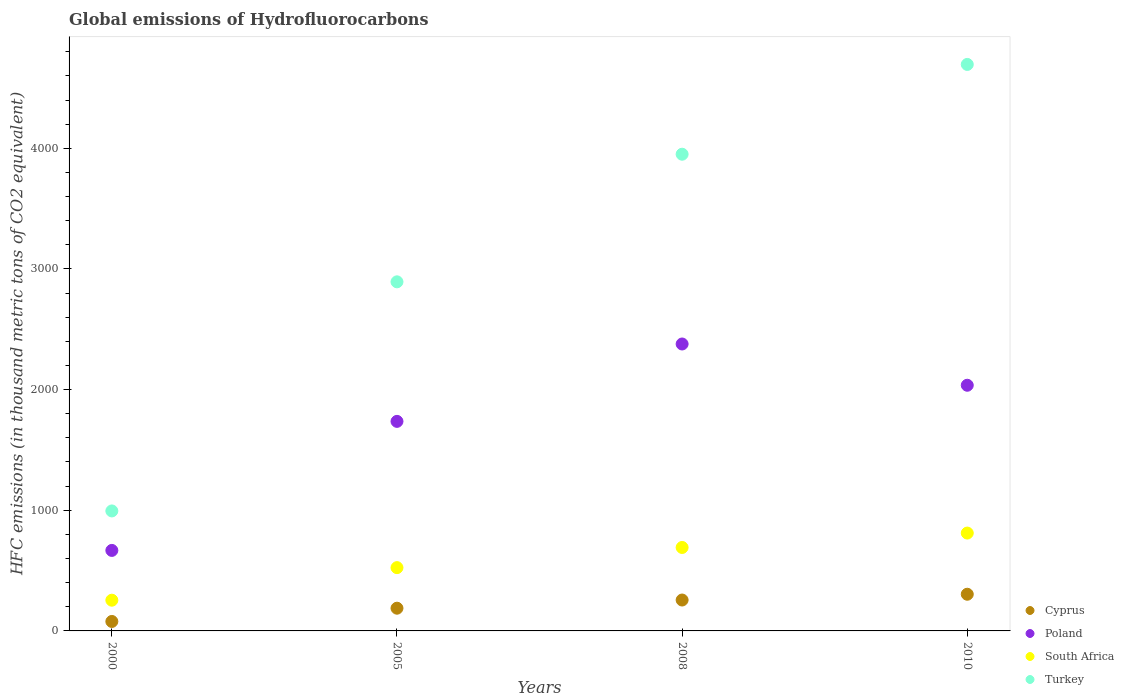How many different coloured dotlines are there?
Keep it short and to the point. 4. Is the number of dotlines equal to the number of legend labels?
Keep it short and to the point. Yes. What is the global emissions of Hydrofluorocarbons in Poland in 2010?
Offer a terse response. 2036. Across all years, what is the maximum global emissions of Hydrofluorocarbons in Poland?
Make the answer very short. 2378. Across all years, what is the minimum global emissions of Hydrofluorocarbons in Turkey?
Your response must be concise. 994.4. What is the total global emissions of Hydrofluorocarbons in Turkey in the graph?
Provide a short and direct response. 1.25e+04. What is the difference between the global emissions of Hydrofluorocarbons in Turkey in 2005 and that in 2008?
Provide a succinct answer. -1057.6. What is the difference between the global emissions of Hydrofluorocarbons in South Africa in 2000 and the global emissions of Hydrofluorocarbons in Turkey in 2010?
Your answer should be very brief. -4440.4. What is the average global emissions of Hydrofluorocarbons in Cyprus per year?
Give a very brief answer. 206.7. In the year 2005, what is the difference between the global emissions of Hydrofluorocarbons in Cyprus and global emissions of Hydrofluorocarbons in South Africa?
Offer a very short reply. -336.2. In how many years, is the global emissions of Hydrofluorocarbons in Cyprus greater than 3000 thousand metric tons?
Give a very brief answer. 0. What is the ratio of the global emissions of Hydrofluorocarbons in Cyprus in 2000 to that in 2010?
Your answer should be compact. 0.26. Is the difference between the global emissions of Hydrofluorocarbons in Cyprus in 2005 and 2010 greater than the difference between the global emissions of Hydrofluorocarbons in South Africa in 2005 and 2010?
Offer a very short reply. Yes. What is the difference between the highest and the second highest global emissions of Hydrofluorocarbons in Turkey?
Offer a very short reply. 744.2. What is the difference between the highest and the lowest global emissions of Hydrofluorocarbons in South Africa?
Keep it short and to the point. 556.4. Is it the case that in every year, the sum of the global emissions of Hydrofluorocarbons in Poland and global emissions of Hydrofluorocarbons in South Africa  is greater than the global emissions of Hydrofluorocarbons in Turkey?
Your response must be concise. No. Does the global emissions of Hydrofluorocarbons in South Africa monotonically increase over the years?
Ensure brevity in your answer.  Yes. Is the global emissions of Hydrofluorocarbons in Poland strictly less than the global emissions of Hydrofluorocarbons in Turkey over the years?
Offer a very short reply. Yes. How many dotlines are there?
Your answer should be very brief. 4. How many years are there in the graph?
Ensure brevity in your answer.  4. Does the graph contain any zero values?
Provide a succinct answer. No. Does the graph contain grids?
Offer a very short reply. No. What is the title of the graph?
Offer a very short reply. Global emissions of Hydrofluorocarbons. What is the label or title of the X-axis?
Keep it short and to the point. Years. What is the label or title of the Y-axis?
Provide a short and direct response. HFC emissions (in thousand metric tons of CO2 equivalent). What is the HFC emissions (in thousand metric tons of CO2 equivalent) of Cyprus in 2000?
Keep it short and to the point. 78.4. What is the HFC emissions (in thousand metric tons of CO2 equivalent) of Poland in 2000?
Provide a succinct answer. 667.2. What is the HFC emissions (in thousand metric tons of CO2 equivalent) of South Africa in 2000?
Your answer should be compact. 254.6. What is the HFC emissions (in thousand metric tons of CO2 equivalent) of Turkey in 2000?
Your answer should be compact. 994.4. What is the HFC emissions (in thousand metric tons of CO2 equivalent) in Cyprus in 2005?
Your answer should be compact. 188.3. What is the HFC emissions (in thousand metric tons of CO2 equivalent) of Poland in 2005?
Give a very brief answer. 1736.7. What is the HFC emissions (in thousand metric tons of CO2 equivalent) of South Africa in 2005?
Your answer should be very brief. 524.5. What is the HFC emissions (in thousand metric tons of CO2 equivalent) of Turkey in 2005?
Your response must be concise. 2893.2. What is the HFC emissions (in thousand metric tons of CO2 equivalent) in Cyprus in 2008?
Provide a succinct answer. 256.1. What is the HFC emissions (in thousand metric tons of CO2 equivalent) in Poland in 2008?
Your answer should be very brief. 2378. What is the HFC emissions (in thousand metric tons of CO2 equivalent) of South Africa in 2008?
Offer a very short reply. 691.6. What is the HFC emissions (in thousand metric tons of CO2 equivalent) of Turkey in 2008?
Provide a short and direct response. 3950.8. What is the HFC emissions (in thousand metric tons of CO2 equivalent) of Cyprus in 2010?
Give a very brief answer. 304. What is the HFC emissions (in thousand metric tons of CO2 equivalent) in Poland in 2010?
Provide a succinct answer. 2036. What is the HFC emissions (in thousand metric tons of CO2 equivalent) of South Africa in 2010?
Give a very brief answer. 811. What is the HFC emissions (in thousand metric tons of CO2 equivalent) in Turkey in 2010?
Ensure brevity in your answer.  4695. Across all years, what is the maximum HFC emissions (in thousand metric tons of CO2 equivalent) in Cyprus?
Make the answer very short. 304. Across all years, what is the maximum HFC emissions (in thousand metric tons of CO2 equivalent) in Poland?
Make the answer very short. 2378. Across all years, what is the maximum HFC emissions (in thousand metric tons of CO2 equivalent) of South Africa?
Your answer should be compact. 811. Across all years, what is the maximum HFC emissions (in thousand metric tons of CO2 equivalent) of Turkey?
Make the answer very short. 4695. Across all years, what is the minimum HFC emissions (in thousand metric tons of CO2 equivalent) in Cyprus?
Keep it short and to the point. 78.4. Across all years, what is the minimum HFC emissions (in thousand metric tons of CO2 equivalent) of Poland?
Provide a succinct answer. 667.2. Across all years, what is the minimum HFC emissions (in thousand metric tons of CO2 equivalent) of South Africa?
Ensure brevity in your answer.  254.6. Across all years, what is the minimum HFC emissions (in thousand metric tons of CO2 equivalent) of Turkey?
Provide a succinct answer. 994.4. What is the total HFC emissions (in thousand metric tons of CO2 equivalent) of Cyprus in the graph?
Provide a succinct answer. 826.8. What is the total HFC emissions (in thousand metric tons of CO2 equivalent) of Poland in the graph?
Offer a very short reply. 6817.9. What is the total HFC emissions (in thousand metric tons of CO2 equivalent) in South Africa in the graph?
Your answer should be compact. 2281.7. What is the total HFC emissions (in thousand metric tons of CO2 equivalent) of Turkey in the graph?
Provide a short and direct response. 1.25e+04. What is the difference between the HFC emissions (in thousand metric tons of CO2 equivalent) in Cyprus in 2000 and that in 2005?
Keep it short and to the point. -109.9. What is the difference between the HFC emissions (in thousand metric tons of CO2 equivalent) in Poland in 2000 and that in 2005?
Provide a short and direct response. -1069.5. What is the difference between the HFC emissions (in thousand metric tons of CO2 equivalent) of South Africa in 2000 and that in 2005?
Make the answer very short. -269.9. What is the difference between the HFC emissions (in thousand metric tons of CO2 equivalent) of Turkey in 2000 and that in 2005?
Offer a very short reply. -1898.8. What is the difference between the HFC emissions (in thousand metric tons of CO2 equivalent) in Cyprus in 2000 and that in 2008?
Your answer should be compact. -177.7. What is the difference between the HFC emissions (in thousand metric tons of CO2 equivalent) of Poland in 2000 and that in 2008?
Provide a succinct answer. -1710.8. What is the difference between the HFC emissions (in thousand metric tons of CO2 equivalent) in South Africa in 2000 and that in 2008?
Offer a very short reply. -437. What is the difference between the HFC emissions (in thousand metric tons of CO2 equivalent) in Turkey in 2000 and that in 2008?
Provide a succinct answer. -2956.4. What is the difference between the HFC emissions (in thousand metric tons of CO2 equivalent) in Cyprus in 2000 and that in 2010?
Provide a succinct answer. -225.6. What is the difference between the HFC emissions (in thousand metric tons of CO2 equivalent) in Poland in 2000 and that in 2010?
Your response must be concise. -1368.8. What is the difference between the HFC emissions (in thousand metric tons of CO2 equivalent) of South Africa in 2000 and that in 2010?
Your answer should be very brief. -556.4. What is the difference between the HFC emissions (in thousand metric tons of CO2 equivalent) of Turkey in 2000 and that in 2010?
Keep it short and to the point. -3700.6. What is the difference between the HFC emissions (in thousand metric tons of CO2 equivalent) of Cyprus in 2005 and that in 2008?
Offer a very short reply. -67.8. What is the difference between the HFC emissions (in thousand metric tons of CO2 equivalent) in Poland in 2005 and that in 2008?
Provide a short and direct response. -641.3. What is the difference between the HFC emissions (in thousand metric tons of CO2 equivalent) in South Africa in 2005 and that in 2008?
Keep it short and to the point. -167.1. What is the difference between the HFC emissions (in thousand metric tons of CO2 equivalent) in Turkey in 2005 and that in 2008?
Provide a short and direct response. -1057.6. What is the difference between the HFC emissions (in thousand metric tons of CO2 equivalent) of Cyprus in 2005 and that in 2010?
Provide a succinct answer. -115.7. What is the difference between the HFC emissions (in thousand metric tons of CO2 equivalent) of Poland in 2005 and that in 2010?
Make the answer very short. -299.3. What is the difference between the HFC emissions (in thousand metric tons of CO2 equivalent) of South Africa in 2005 and that in 2010?
Offer a very short reply. -286.5. What is the difference between the HFC emissions (in thousand metric tons of CO2 equivalent) in Turkey in 2005 and that in 2010?
Provide a succinct answer. -1801.8. What is the difference between the HFC emissions (in thousand metric tons of CO2 equivalent) of Cyprus in 2008 and that in 2010?
Provide a short and direct response. -47.9. What is the difference between the HFC emissions (in thousand metric tons of CO2 equivalent) of Poland in 2008 and that in 2010?
Your answer should be compact. 342. What is the difference between the HFC emissions (in thousand metric tons of CO2 equivalent) of South Africa in 2008 and that in 2010?
Give a very brief answer. -119.4. What is the difference between the HFC emissions (in thousand metric tons of CO2 equivalent) in Turkey in 2008 and that in 2010?
Your answer should be very brief. -744.2. What is the difference between the HFC emissions (in thousand metric tons of CO2 equivalent) in Cyprus in 2000 and the HFC emissions (in thousand metric tons of CO2 equivalent) in Poland in 2005?
Offer a very short reply. -1658.3. What is the difference between the HFC emissions (in thousand metric tons of CO2 equivalent) in Cyprus in 2000 and the HFC emissions (in thousand metric tons of CO2 equivalent) in South Africa in 2005?
Your answer should be compact. -446.1. What is the difference between the HFC emissions (in thousand metric tons of CO2 equivalent) of Cyprus in 2000 and the HFC emissions (in thousand metric tons of CO2 equivalent) of Turkey in 2005?
Keep it short and to the point. -2814.8. What is the difference between the HFC emissions (in thousand metric tons of CO2 equivalent) in Poland in 2000 and the HFC emissions (in thousand metric tons of CO2 equivalent) in South Africa in 2005?
Ensure brevity in your answer.  142.7. What is the difference between the HFC emissions (in thousand metric tons of CO2 equivalent) in Poland in 2000 and the HFC emissions (in thousand metric tons of CO2 equivalent) in Turkey in 2005?
Keep it short and to the point. -2226. What is the difference between the HFC emissions (in thousand metric tons of CO2 equivalent) of South Africa in 2000 and the HFC emissions (in thousand metric tons of CO2 equivalent) of Turkey in 2005?
Provide a succinct answer. -2638.6. What is the difference between the HFC emissions (in thousand metric tons of CO2 equivalent) of Cyprus in 2000 and the HFC emissions (in thousand metric tons of CO2 equivalent) of Poland in 2008?
Keep it short and to the point. -2299.6. What is the difference between the HFC emissions (in thousand metric tons of CO2 equivalent) of Cyprus in 2000 and the HFC emissions (in thousand metric tons of CO2 equivalent) of South Africa in 2008?
Your answer should be compact. -613.2. What is the difference between the HFC emissions (in thousand metric tons of CO2 equivalent) in Cyprus in 2000 and the HFC emissions (in thousand metric tons of CO2 equivalent) in Turkey in 2008?
Give a very brief answer. -3872.4. What is the difference between the HFC emissions (in thousand metric tons of CO2 equivalent) of Poland in 2000 and the HFC emissions (in thousand metric tons of CO2 equivalent) of South Africa in 2008?
Provide a short and direct response. -24.4. What is the difference between the HFC emissions (in thousand metric tons of CO2 equivalent) of Poland in 2000 and the HFC emissions (in thousand metric tons of CO2 equivalent) of Turkey in 2008?
Provide a succinct answer. -3283.6. What is the difference between the HFC emissions (in thousand metric tons of CO2 equivalent) in South Africa in 2000 and the HFC emissions (in thousand metric tons of CO2 equivalent) in Turkey in 2008?
Keep it short and to the point. -3696.2. What is the difference between the HFC emissions (in thousand metric tons of CO2 equivalent) in Cyprus in 2000 and the HFC emissions (in thousand metric tons of CO2 equivalent) in Poland in 2010?
Ensure brevity in your answer.  -1957.6. What is the difference between the HFC emissions (in thousand metric tons of CO2 equivalent) of Cyprus in 2000 and the HFC emissions (in thousand metric tons of CO2 equivalent) of South Africa in 2010?
Provide a short and direct response. -732.6. What is the difference between the HFC emissions (in thousand metric tons of CO2 equivalent) in Cyprus in 2000 and the HFC emissions (in thousand metric tons of CO2 equivalent) in Turkey in 2010?
Offer a very short reply. -4616.6. What is the difference between the HFC emissions (in thousand metric tons of CO2 equivalent) in Poland in 2000 and the HFC emissions (in thousand metric tons of CO2 equivalent) in South Africa in 2010?
Your answer should be very brief. -143.8. What is the difference between the HFC emissions (in thousand metric tons of CO2 equivalent) of Poland in 2000 and the HFC emissions (in thousand metric tons of CO2 equivalent) of Turkey in 2010?
Provide a short and direct response. -4027.8. What is the difference between the HFC emissions (in thousand metric tons of CO2 equivalent) of South Africa in 2000 and the HFC emissions (in thousand metric tons of CO2 equivalent) of Turkey in 2010?
Your answer should be very brief. -4440.4. What is the difference between the HFC emissions (in thousand metric tons of CO2 equivalent) in Cyprus in 2005 and the HFC emissions (in thousand metric tons of CO2 equivalent) in Poland in 2008?
Offer a terse response. -2189.7. What is the difference between the HFC emissions (in thousand metric tons of CO2 equivalent) of Cyprus in 2005 and the HFC emissions (in thousand metric tons of CO2 equivalent) of South Africa in 2008?
Give a very brief answer. -503.3. What is the difference between the HFC emissions (in thousand metric tons of CO2 equivalent) of Cyprus in 2005 and the HFC emissions (in thousand metric tons of CO2 equivalent) of Turkey in 2008?
Provide a succinct answer. -3762.5. What is the difference between the HFC emissions (in thousand metric tons of CO2 equivalent) in Poland in 2005 and the HFC emissions (in thousand metric tons of CO2 equivalent) in South Africa in 2008?
Offer a terse response. 1045.1. What is the difference between the HFC emissions (in thousand metric tons of CO2 equivalent) in Poland in 2005 and the HFC emissions (in thousand metric tons of CO2 equivalent) in Turkey in 2008?
Offer a very short reply. -2214.1. What is the difference between the HFC emissions (in thousand metric tons of CO2 equivalent) of South Africa in 2005 and the HFC emissions (in thousand metric tons of CO2 equivalent) of Turkey in 2008?
Offer a very short reply. -3426.3. What is the difference between the HFC emissions (in thousand metric tons of CO2 equivalent) in Cyprus in 2005 and the HFC emissions (in thousand metric tons of CO2 equivalent) in Poland in 2010?
Give a very brief answer. -1847.7. What is the difference between the HFC emissions (in thousand metric tons of CO2 equivalent) in Cyprus in 2005 and the HFC emissions (in thousand metric tons of CO2 equivalent) in South Africa in 2010?
Ensure brevity in your answer.  -622.7. What is the difference between the HFC emissions (in thousand metric tons of CO2 equivalent) in Cyprus in 2005 and the HFC emissions (in thousand metric tons of CO2 equivalent) in Turkey in 2010?
Give a very brief answer. -4506.7. What is the difference between the HFC emissions (in thousand metric tons of CO2 equivalent) in Poland in 2005 and the HFC emissions (in thousand metric tons of CO2 equivalent) in South Africa in 2010?
Give a very brief answer. 925.7. What is the difference between the HFC emissions (in thousand metric tons of CO2 equivalent) in Poland in 2005 and the HFC emissions (in thousand metric tons of CO2 equivalent) in Turkey in 2010?
Keep it short and to the point. -2958.3. What is the difference between the HFC emissions (in thousand metric tons of CO2 equivalent) in South Africa in 2005 and the HFC emissions (in thousand metric tons of CO2 equivalent) in Turkey in 2010?
Keep it short and to the point. -4170.5. What is the difference between the HFC emissions (in thousand metric tons of CO2 equivalent) in Cyprus in 2008 and the HFC emissions (in thousand metric tons of CO2 equivalent) in Poland in 2010?
Offer a terse response. -1779.9. What is the difference between the HFC emissions (in thousand metric tons of CO2 equivalent) in Cyprus in 2008 and the HFC emissions (in thousand metric tons of CO2 equivalent) in South Africa in 2010?
Keep it short and to the point. -554.9. What is the difference between the HFC emissions (in thousand metric tons of CO2 equivalent) in Cyprus in 2008 and the HFC emissions (in thousand metric tons of CO2 equivalent) in Turkey in 2010?
Your answer should be compact. -4438.9. What is the difference between the HFC emissions (in thousand metric tons of CO2 equivalent) in Poland in 2008 and the HFC emissions (in thousand metric tons of CO2 equivalent) in South Africa in 2010?
Make the answer very short. 1567. What is the difference between the HFC emissions (in thousand metric tons of CO2 equivalent) of Poland in 2008 and the HFC emissions (in thousand metric tons of CO2 equivalent) of Turkey in 2010?
Offer a terse response. -2317. What is the difference between the HFC emissions (in thousand metric tons of CO2 equivalent) in South Africa in 2008 and the HFC emissions (in thousand metric tons of CO2 equivalent) in Turkey in 2010?
Make the answer very short. -4003.4. What is the average HFC emissions (in thousand metric tons of CO2 equivalent) of Cyprus per year?
Keep it short and to the point. 206.7. What is the average HFC emissions (in thousand metric tons of CO2 equivalent) of Poland per year?
Provide a succinct answer. 1704.47. What is the average HFC emissions (in thousand metric tons of CO2 equivalent) in South Africa per year?
Provide a short and direct response. 570.42. What is the average HFC emissions (in thousand metric tons of CO2 equivalent) in Turkey per year?
Offer a very short reply. 3133.35. In the year 2000, what is the difference between the HFC emissions (in thousand metric tons of CO2 equivalent) in Cyprus and HFC emissions (in thousand metric tons of CO2 equivalent) in Poland?
Provide a short and direct response. -588.8. In the year 2000, what is the difference between the HFC emissions (in thousand metric tons of CO2 equivalent) in Cyprus and HFC emissions (in thousand metric tons of CO2 equivalent) in South Africa?
Give a very brief answer. -176.2. In the year 2000, what is the difference between the HFC emissions (in thousand metric tons of CO2 equivalent) in Cyprus and HFC emissions (in thousand metric tons of CO2 equivalent) in Turkey?
Offer a terse response. -916. In the year 2000, what is the difference between the HFC emissions (in thousand metric tons of CO2 equivalent) of Poland and HFC emissions (in thousand metric tons of CO2 equivalent) of South Africa?
Your answer should be compact. 412.6. In the year 2000, what is the difference between the HFC emissions (in thousand metric tons of CO2 equivalent) in Poland and HFC emissions (in thousand metric tons of CO2 equivalent) in Turkey?
Your response must be concise. -327.2. In the year 2000, what is the difference between the HFC emissions (in thousand metric tons of CO2 equivalent) of South Africa and HFC emissions (in thousand metric tons of CO2 equivalent) of Turkey?
Your response must be concise. -739.8. In the year 2005, what is the difference between the HFC emissions (in thousand metric tons of CO2 equivalent) in Cyprus and HFC emissions (in thousand metric tons of CO2 equivalent) in Poland?
Your answer should be very brief. -1548.4. In the year 2005, what is the difference between the HFC emissions (in thousand metric tons of CO2 equivalent) in Cyprus and HFC emissions (in thousand metric tons of CO2 equivalent) in South Africa?
Your answer should be compact. -336.2. In the year 2005, what is the difference between the HFC emissions (in thousand metric tons of CO2 equivalent) in Cyprus and HFC emissions (in thousand metric tons of CO2 equivalent) in Turkey?
Make the answer very short. -2704.9. In the year 2005, what is the difference between the HFC emissions (in thousand metric tons of CO2 equivalent) in Poland and HFC emissions (in thousand metric tons of CO2 equivalent) in South Africa?
Keep it short and to the point. 1212.2. In the year 2005, what is the difference between the HFC emissions (in thousand metric tons of CO2 equivalent) in Poland and HFC emissions (in thousand metric tons of CO2 equivalent) in Turkey?
Offer a terse response. -1156.5. In the year 2005, what is the difference between the HFC emissions (in thousand metric tons of CO2 equivalent) of South Africa and HFC emissions (in thousand metric tons of CO2 equivalent) of Turkey?
Provide a short and direct response. -2368.7. In the year 2008, what is the difference between the HFC emissions (in thousand metric tons of CO2 equivalent) in Cyprus and HFC emissions (in thousand metric tons of CO2 equivalent) in Poland?
Keep it short and to the point. -2121.9. In the year 2008, what is the difference between the HFC emissions (in thousand metric tons of CO2 equivalent) of Cyprus and HFC emissions (in thousand metric tons of CO2 equivalent) of South Africa?
Your answer should be very brief. -435.5. In the year 2008, what is the difference between the HFC emissions (in thousand metric tons of CO2 equivalent) in Cyprus and HFC emissions (in thousand metric tons of CO2 equivalent) in Turkey?
Provide a short and direct response. -3694.7. In the year 2008, what is the difference between the HFC emissions (in thousand metric tons of CO2 equivalent) in Poland and HFC emissions (in thousand metric tons of CO2 equivalent) in South Africa?
Offer a terse response. 1686.4. In the year 2008, what is the difference between the HFC emissions (in thousand metric tons of CO2 equivalent) in Poland and HFC emissions (in thousand metric tons of CO2 equivalent) in Turkey?
Your answer should be compact. -1572.8. In the year 2008, what is the difference between the HFC emissions (in thousand metric tons of CO2 equivalent) in South Africa and HFC emissions (in thousand metric tons of CO2 equivalent) in Turkey?
Keep it short and to the point. -3259.2. In the year 2010, what is the difference between the HFC emissions (in thousand metric tons of CO2 equivalent) in Cyprus and HFC emissions (in thousand metric tons of CO2 equivalent) in Poland?
Give a very brief answer. -1732. In the year 2010, what is the difference between the HFC emissions (in thousand metric tons of CO2 equivalent) in Cyprus and HFC emissions (in thousand metric tons of CO2 equivalent) in South Africa?
Offer a very short reply. -507. In the year 2010, what is the difference between the HFC emissions (in thousand metric tons of CO2 equivalent) of Cyprus and HFC emissions (in thousand metric tons of CO2 equivalent) of Turkey?
Ensure brevity in your answer.  -4391. In the year 2010, what is the difference between the HFC emissions (in thousand metric tons of CO2 equivalent) in Poland and HFC emissions (in thousand metric tons of CO2 equivalent) in South Africa?
Offer a very short reply. 1225. In the year 2010, what is the difference between the HFC emissions (in thousand metric tons of CO2 equivalent) of Poland and HFC emissions (in thousand metric tons of CO2 equivalent) of Turkey?
Provide a succinct answer. -2659. In the year 2010, what is the difference between the HFC emissions (in thousand metric tons of CO2 equivalent) in South Africa and HFC emissions (in thousand metric tons of CO2 equivalent) in Turkey?
Keep it short and to the point. -3884. What is the ratio of the HFC emissions (in thousand metric tons of CO2 equivalent) of Cyprus in 2000 to that in 2005?
Ensure brevity in your answer.  0.42. What is the ratio of the HFC emissions (in thousand metric tons of CO2 equivalent) in Poland in 2000 to that in 2005?
Make the answer very short. 0.38. What is the ratio of the HFC emissions (in thousand metric tons of CO2 equivalent) of South Africa in 2000 to that in 2005?
Your response must be concise. 0.49. What is the ratio of the HFC emissions (in thousand metric tons of CO2 equivalent) in Turkey in 2000 to that in 2005?
Keep it short and to the point. 0.34. What is the ratio of the HFC emissions (in thousand metric tons of CO2 equivalent) of Cyprus in 2000 to that in 2008?
Your answer should be compact. 0.31. What is the ratio of the HFC emissions (in thousand metric tons of CO2 equivalent) of Poland in 2000 to that in 2008?
Provide a succinct answer. 0.28. What is the ratio of the HFC emissions (in thousand metric tons of CO2 equivalent) in South Africa in 2000 to that in 2008?
Make the answer very short. 0.37. What is the ratio of the HFC emissions (in thousand metric tons of CO2 equivalent) of Turkey in 2000 to that in 2008?
Give a very brief answer. 0.25. What is the ratio of the HFC emissions (in thousand metric tons of CO2 equivalent) in Cyprus in 2000 to that in 2010?
Make the answer very short. 0.26. What is the ratio of the HFC emissions (in thousand metric tons of CO2 equivalent) in Poland in 2000 to that in 2010?
Offer a very short reply. 0.33. What is the ratio of the HFC emissions (in thousand metric tons of CO2 equivalent) in South Africa in 2000 to that in 2010?
Provide a succinct answer. 0.31. What is the ratio of the HFC emissions (in thousand metric tons of CO2 equivalent) of Turkey in 2000 to that in 2010?
Give a very brief answer. 0.21. What is the ratio of the HFC emissions (in thousand metric tons of CO2 equivalent) in Cyprus in 2005 to that in 2008?
Provide a short and direct response. 0.74. What is the ratio of the HFC emissions (in thousand metric tons of CO2 equivalent) of Poland in 2005 to that in 2008?
Offer a very short reply. 0.73. What is the ratio of the HFC emissions (in thousand metric tons of CO2 equivalent) in South Africa in 2005 to that in 2008?
Offer a terse response. 0.76. What is the ratio of the HFC emissions (in thousand metric tons of CO2 equivalent) of Turkey in 2005 to that in 2008?
Offer a terse response. 0.73. What is the ratio of the HFC emissions (in thousand metric tons of CO2 equivalent) in Cyprus in 2005 to that in 2010?
Offer a very short reply. 0.62. What is the ratio of the HFC emissions (in thousand metric tons of CO2 equivalent) in Poland in 2005 to that in 2010?
Your answer should be compact. 0.85. What is the ratio of the HFC emissions (in thousand metric tons of CO2 equivalent) in South Africa in 2005 to that in 2010?
Provide a succinct answer. 0.65. What is the ratio of the HFC emissions (in thousand metric tons of CO2 equivalent) of Turkey in 2005 to that in 2010?
Make the answer very short. 0.62. What is the ratio of the HFC emissions (in thousand metric tons of CO2 equivalent) in Cyprus in 2008 to that in 2010?
Give a very brief answer. 0.84. What is the ratio of the HFC emissions (in thousand metric tons of CO2 equivalent) of Poland in 2008 to that in 2010?
Provide a succinct answer. 1.17. What is the ratio of the HFC emissions (in thousand metric tons of CO2 equivalent) of South Africa in 2008 to that in 2010?
Ensure brevity in your answer.  0.85. What is the ratio of the HFC emissions (in thousand metric tons of CO2 equivalent) in Turkey in 2008 to that in 2010?
Provide a succinct answer. 0.84. What is the difference between the highest and the second highest HFC emissions (in thousand metric tons of CO2 equivalent) in Cyprus?
Your response must be concise. 47.9. What is the difference between the highest and the second highest HFC emissions (in thousand metric tons of CO2 equivalent) in Poland?
Give a very brief answer. 342. What is the difference between the highest and the second highest HFC emissions (in thousand metric tons of CO2 equivalent) of South Africa?
Ensure brevity in your answer.  119.4. What is the difference between the highest and the second highest HFC emissions (in thousand metric tons of CO2 equivalent) in Turkey?
Offer a terse response. 744.2. What is the difference between the highest and the lowest HFC emissions (in thousand metric tons of CO2 equivalent) in Cyprus?
Offer a very short reply. 225.6. What is the difference between the highest and the lowest HFC emissions (in thousand metric tons of CO2 equivalent) of Poland?
Offer a very short reply. 1710.8. What is the difference between the highest and the lowest HFC emissions (in thousand metric tons of CO2 equivalent) in South Africa?
Provide a succinct answer. 556.4. What is the difference between the highest and the lowest HFC emissions (in thousand metric tons of CO2 equivalent) of Turkey?
Offer a very short reply. 3700.6. 